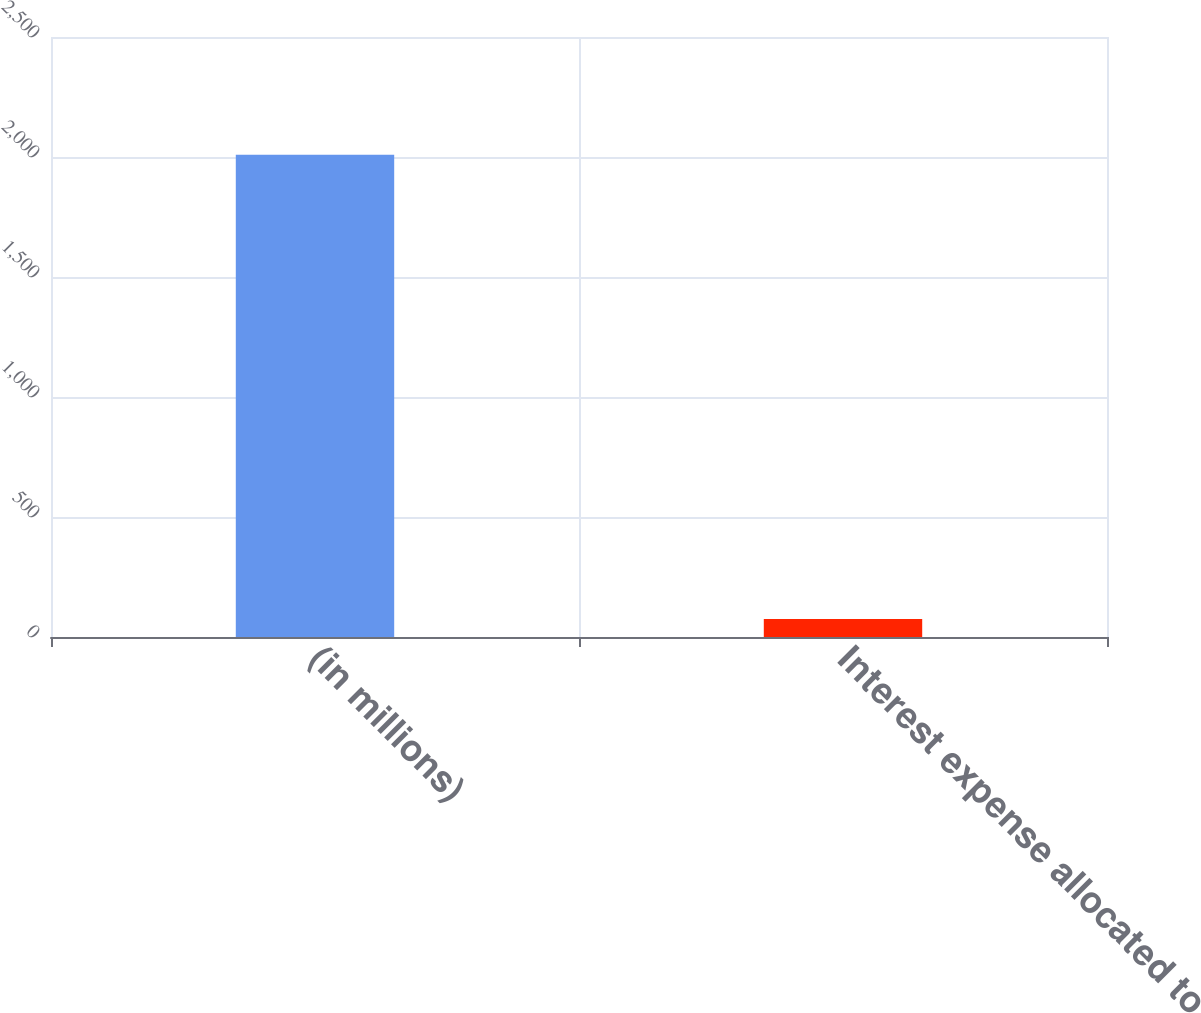<chart> <loc_0><loc_0><loc_500><loc_500><bar_chart><fcel>(in millions)<fcel>Interest expense allocated to<nl><fcel>2009<fcel>75.2<nl></chart> 